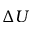<formula> <loc_0><loc_0><loc_500><loc_500>\Delta U</formula> 